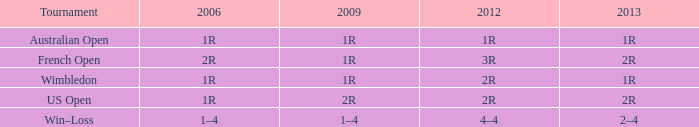What shows for 2006, when 2013 is 2–4? 1–4. 